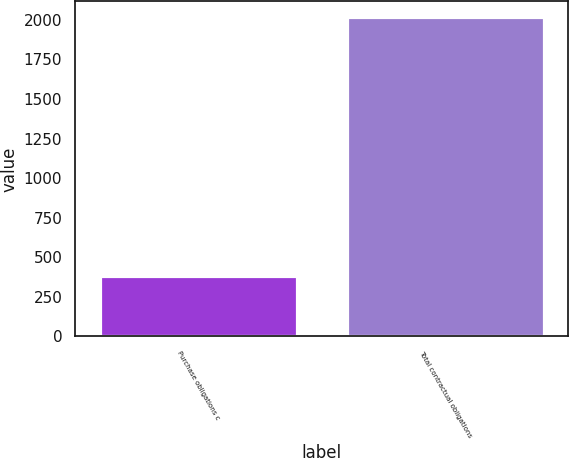Convert chart to OTSL. <chart><loc_0><loc_0><loc_500><loc_500><bar_chart><fcel>Purchase obligations c<fcel>Total contractual obligations<nl><fcel>384<fcel>2016<nl></chart> 